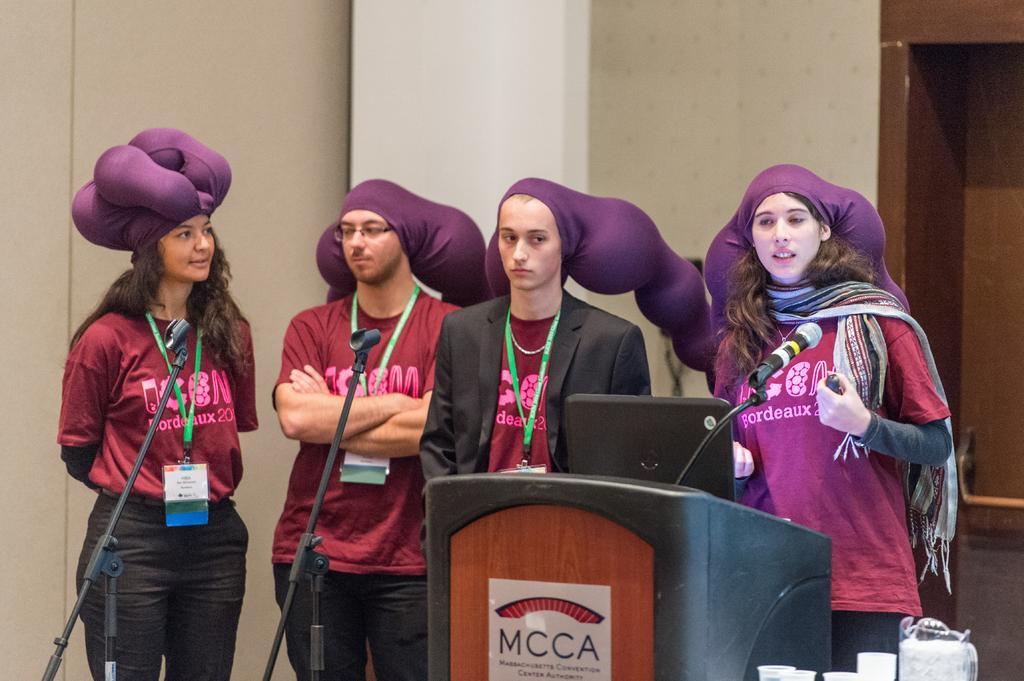Could you give a brief overview of what you see in this image? In this picture we can see a few people standing on the path. There are stands, mics, laptop and a poster on the podium. We can see a few glasses on the right side. A wall is visible in the background. 